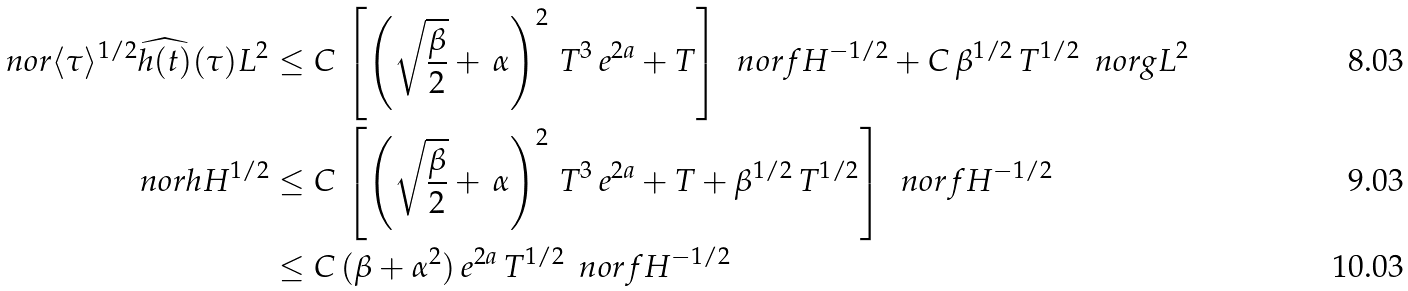<formula> <loc_0><loc_0><loc_500><loc_500>\ n o r { \langle \tau \rangle ^ { 1 / 2 } \widehat { h ( t ) } ( \tau ) } { L ^ { 2 } } & \leq C \, \left [ \left ( \sqrt { \frac { \beta } { 2 } } + \, \alpha \right ) ^ { 2 } \, T ^ { 3 } \, e ^ { 2 a } + T \right ] \, \ n o r { f } { H ^ { - 1 / 2 } } + C \, \beta ^ { 1 / 2 } \, T ^ { 1 / 2 } \, \ n o r { g } { L ^ { 2 } } \\ \ n o r { h } { H ^ { 1 / 2 } } & \leq C \, \left [ \left ( \sqrt { \frac { \beta } { 2 } } + \, \alpha \right ) ^ { 2 } \, T ^ { 3 } \, e ^ { 2 a } + T + \beta ^ { 1 / 2 } \, T ^ { 1 / 2 } \right ] \, \ n o r { f } { H ^ { - 1 / 2 } } \\ & \leq C \, ( \beta + \alpha ^ { 2 } ) \, e ^ { 2 a } \, T ^ { 1 / 2 } \, \ n o r { f } { H ^ { - 1 / 2 } }</formula> 